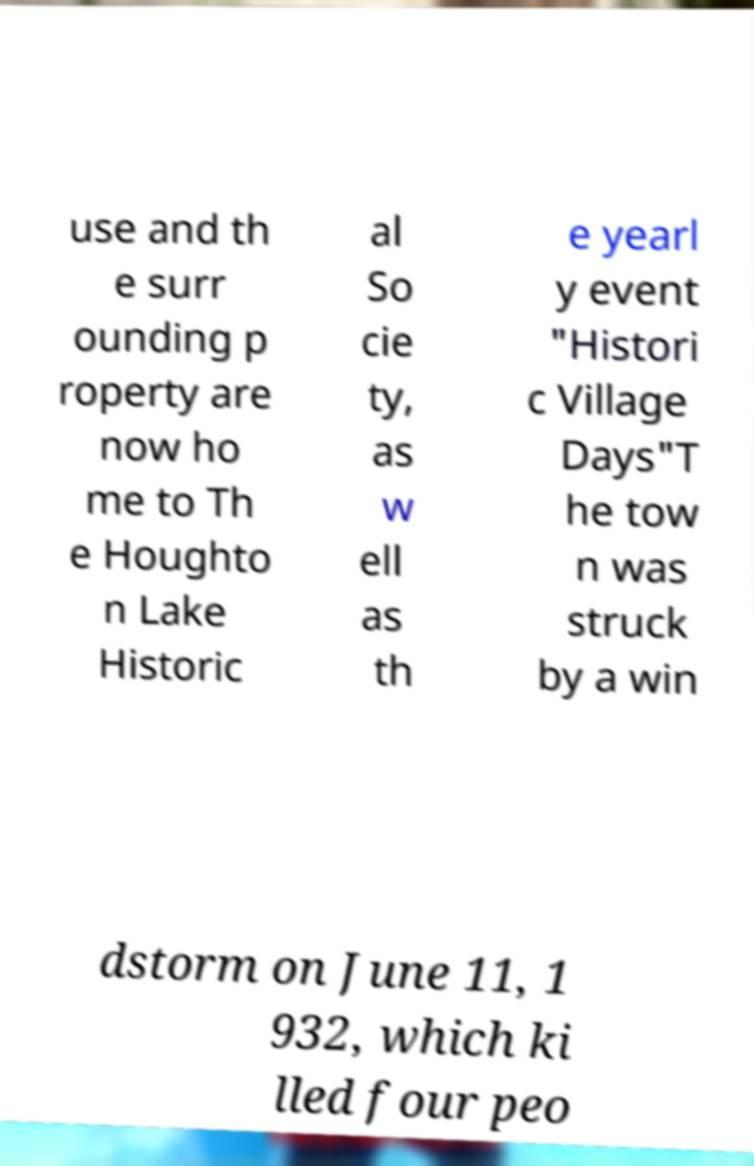I need the written content from this picture converted into text. Can you do that? use and th e surr ounding p roperty are now ho me to Th e Houghto n Lake Historic al So cie ty, as w ell as th e yearl y event "Histori c Village Days"T he tow n was struck by a win dstorm on June 11, 1 932, which ki lled four peo 